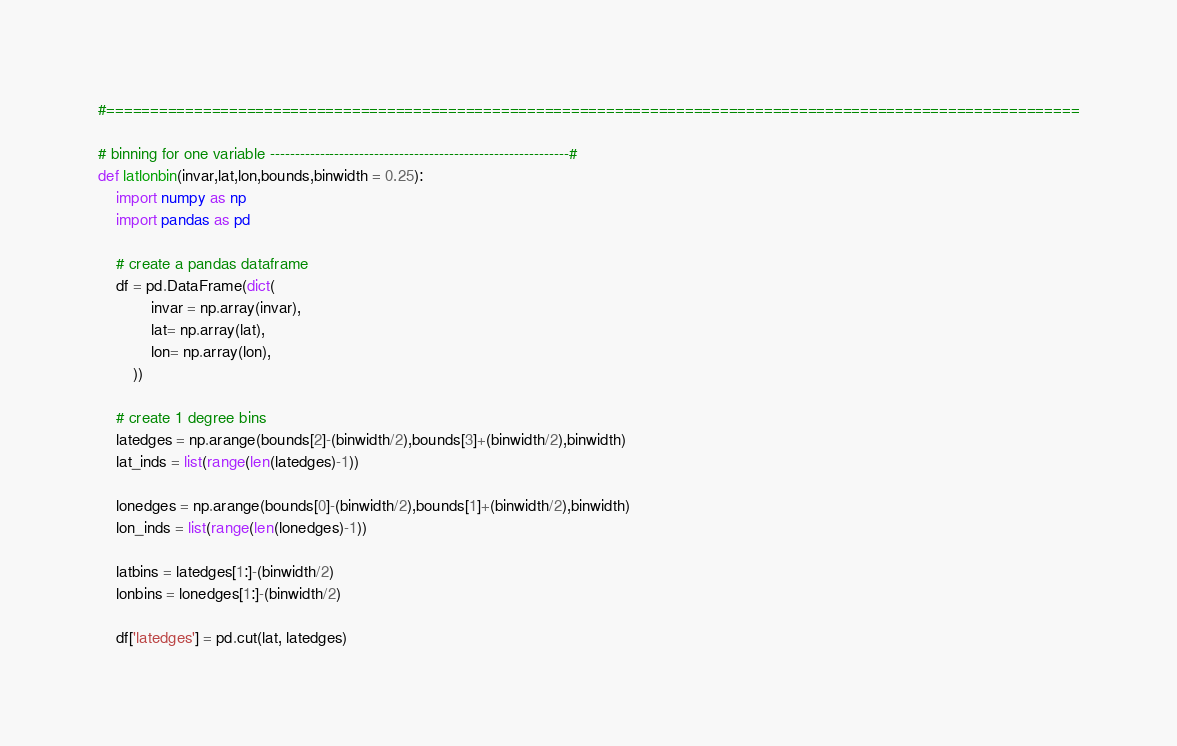<code> <loc_0><loc_0><loc_500><loc_500><_Python_>#===============================================================================================================

# binning for one variable ------------------------------------------------------------#
def latlonbin(invar,lat,lon,bounds,binwidth = 0.25):
    import numpy as np
    import pandas as pd
    
    # create a pandas dataframe
    df = pd.DataFrame(dict(
            invar = np.array(invar),
            lat= np.array(lat),
            lon= np.array(lon),
        ))

    # create 1 degree bins
    latedges = np.arange(bounds[2]-(binwidth/2),bounds[3]+(binwidth/2),binwidth)
    lat_inds = list(range(len(latedges)-1))

    lonedges = np.arange(bounds[0]-(binwidth/2),bounds[1]+(binwidth/2),binwidth)
    lon_inds = list(range(len(lonedges)-1))

    latbins = latedges[1:]-(binwidth/2)
    lonbins = lonedges[1:]-(binwidth/2)

    df['latedges'] = pd.cut(lat, latedges)</code> 